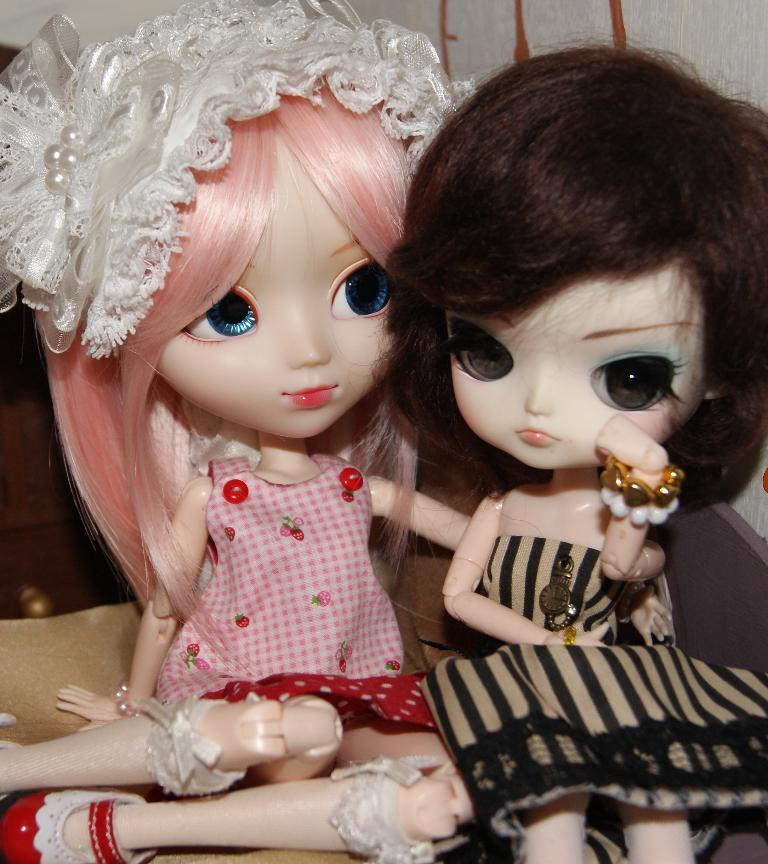How many toys are present in the image? There are two toys in the image. What colors are the dresses of the toys? One toy has a pink dress, and the other toy has a black dress. What is the taste of the pink dress on the toy? Toys do not have a taste, as they are inanimate objects. 